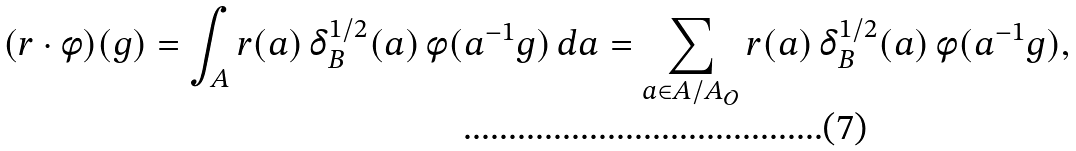<formula> <loc_0><loc_0><loc_500><loc_500>( r \cdot \phi ) ( g ) = \int _ { A } r ( a ) \, \delta _ { B } ^ { 1 / 2 } ( a ) \, \phi ( a ^ { - 1 } g ) \, d a = \sum _ { a \in A / A _ { \mathcal { O } } } r ( a ) \, \delta _ { B } ^ { 1 / 2 } ( a ) \, \phi ( a ^ { - 1 } g ) ,</formula> 